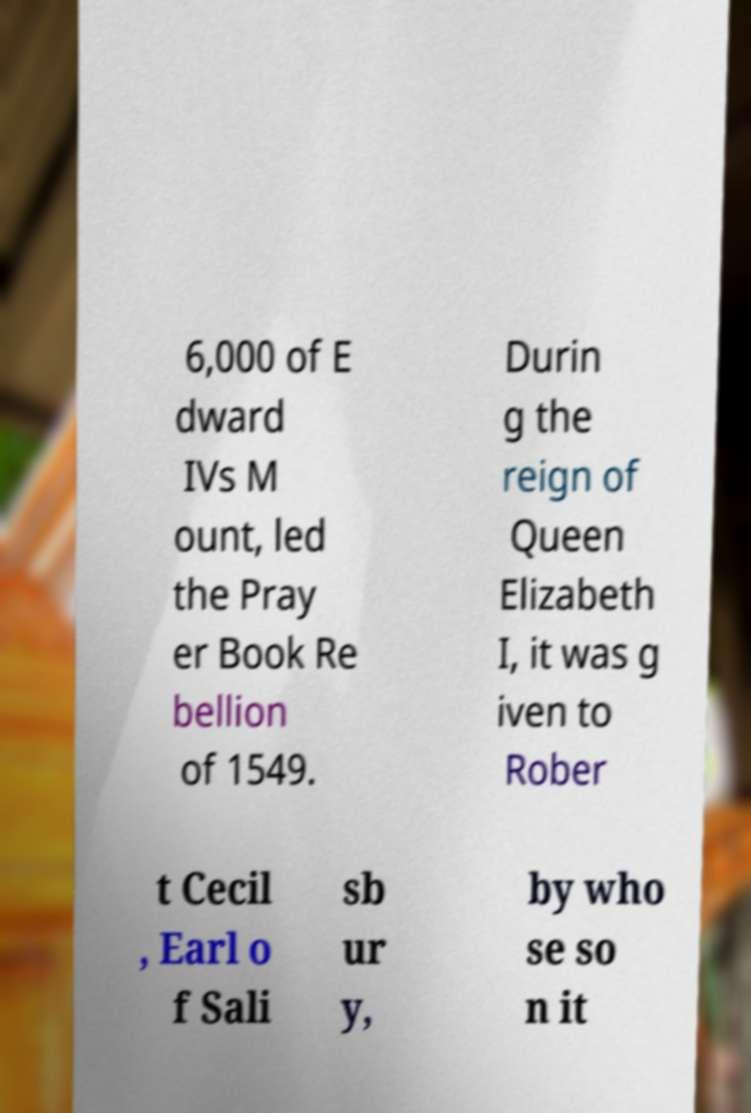I need the written content from this picture converted into text. Can you do that? 6,000 of E dward IVs M ount, led the Pray er Book Re bellion of 1549. Durin g the reign of Queen Elizabeth I, it was g iven to Rober t Cecil , Earl o f Sali sb ur y, by who se so n it 